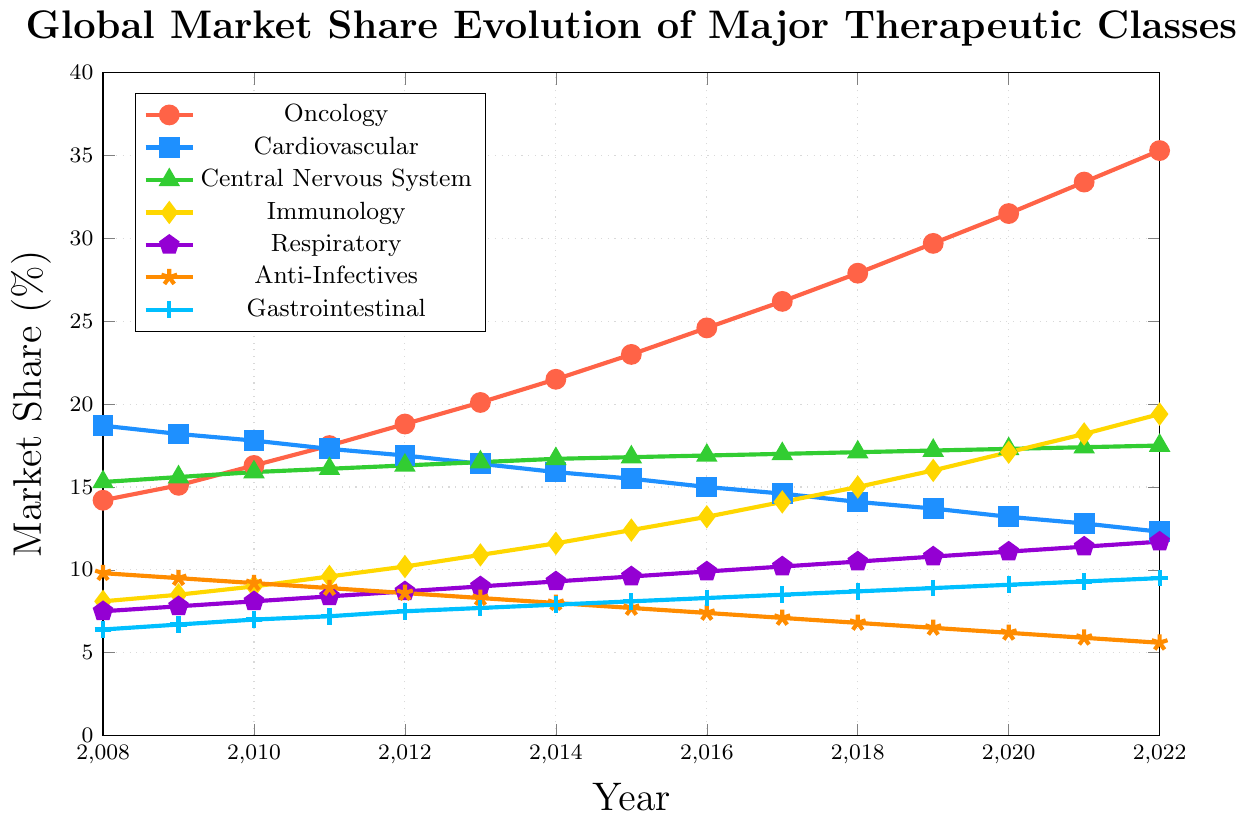Which therapeutic class had the largest market share in 2022? Check the figure at 2022 and identify which category has the highest percentage
Answer: Oncology By how much did the market share of Anti-Infectives decrease from 2008 to 2022? Subtract the 2022 value of Anti-Infectives from the 2008 value: 9.8% - 5.6% = 4.2%
Answer: 4.2% Which therapeutic class exhibited the most growth in market share from 2008 to 2022? Calculate the difference in market share for each class from 2008 to 2022, then identify the maximum: Oncology (35.3% - 14.2% = 21.1%), CNS (17.5% - 15.3% = 2.2%), etc.
Answer: Oncology Did the market share of Central Nervous System grow more or less than that of Immunology from 2008 to 2022? Calculate the growth in percentage for both classes and compare: CNS (2.2%) vs Immunology (11.3%)
Answer: Less Which therapeutic class had a consistent increase in market share every year? Look at the trend lines for each therapeutic class and identify the one that shows a consistent increase every year
Answer: Immunology, CNS What was the combined market share of Respiratory and Gastrointestinal in 2020? Add the 2020 values of Respiratory (11.1%) and Gastrointestinal (9.1%): 11.1% + 9.1% = 20.2%
Answer: 20.2% In which year did Oncology surpass the 20% market share mark? Find the first occurrence where the Oncology percentage exceeds 20% in the timeline
Answer: 2013 Which therapeutic class had the sharpest decline in market share from 2008 to 2022? Identify the therapeutic class that had the largest negative change in percentage: Anti-Infectives (-4.2%), Cardiovascular (-6.4%)
Answer: Cardiovascular What is the average market share of Cardiovascular over the 15 years? Sum all Cardiovascular values from 2008 to 2022 and divide by 15: (18.7 + 18.2 + 17.8 + 17.3 + 16.9 + 16.4 + 15.9 + 15.5 + 15.0 + 14.6 + 14.1 + 13.7 + 13.2 + 12.8 + 12.3) / 15 ≈ 15.4%
Answer: 15.4% 